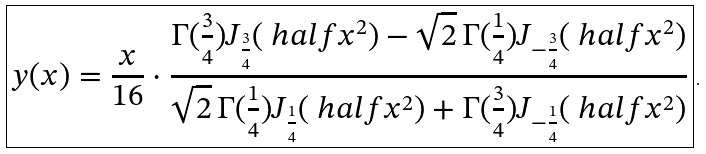Convert formula to latex. <formula><loc_0><loc_0><loc_500><loc_500>\boxed { y ( x ) = \frac { x } { 1 6 } \cdot \frac { \Gamma ( \frac { 3 } { 4 } ) J _ { \frac { 3 } { 4 } } ( \ h a l f x ^ { 2 } ) - \sqrt { 2 } \, \Gamma ( \frac { 1 } { 4 } ) J _ { - \frac { 3 } { 4 } } ( \ h a l f x ^ { 2 } ) } { \sqrt { 2 } \, \Gamma ( \frac { 1 } { 4 } ) J _ { \frac { 1 } { 4 } } ( \ h a l f x ^ { 2 } ) + \Gamma ( \frac { 3 } { 4 } ) J _ { - \frac { 1 } { 4 } } ( \ h a l f x ^ { 2 } ) } } \, .</formula> 